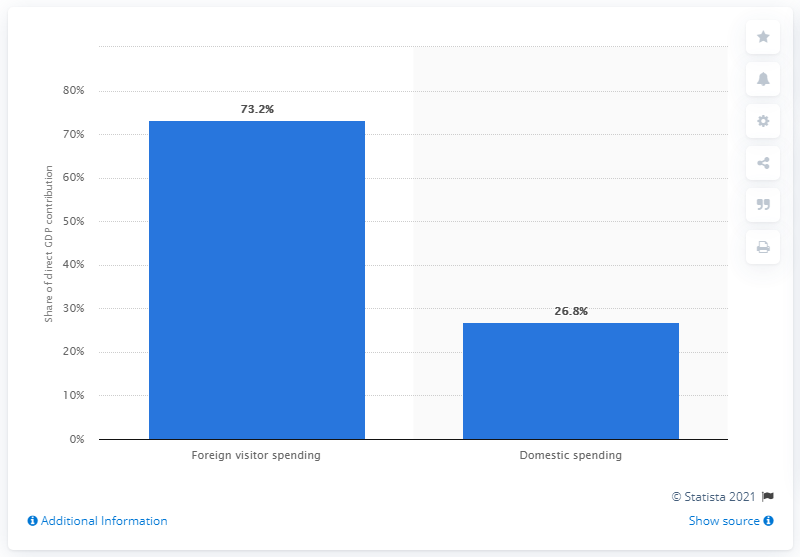Outline some significant characteristics in this image. In 2017, the percentage of foreign visitors to Hungary's GDP was 73.2%. 